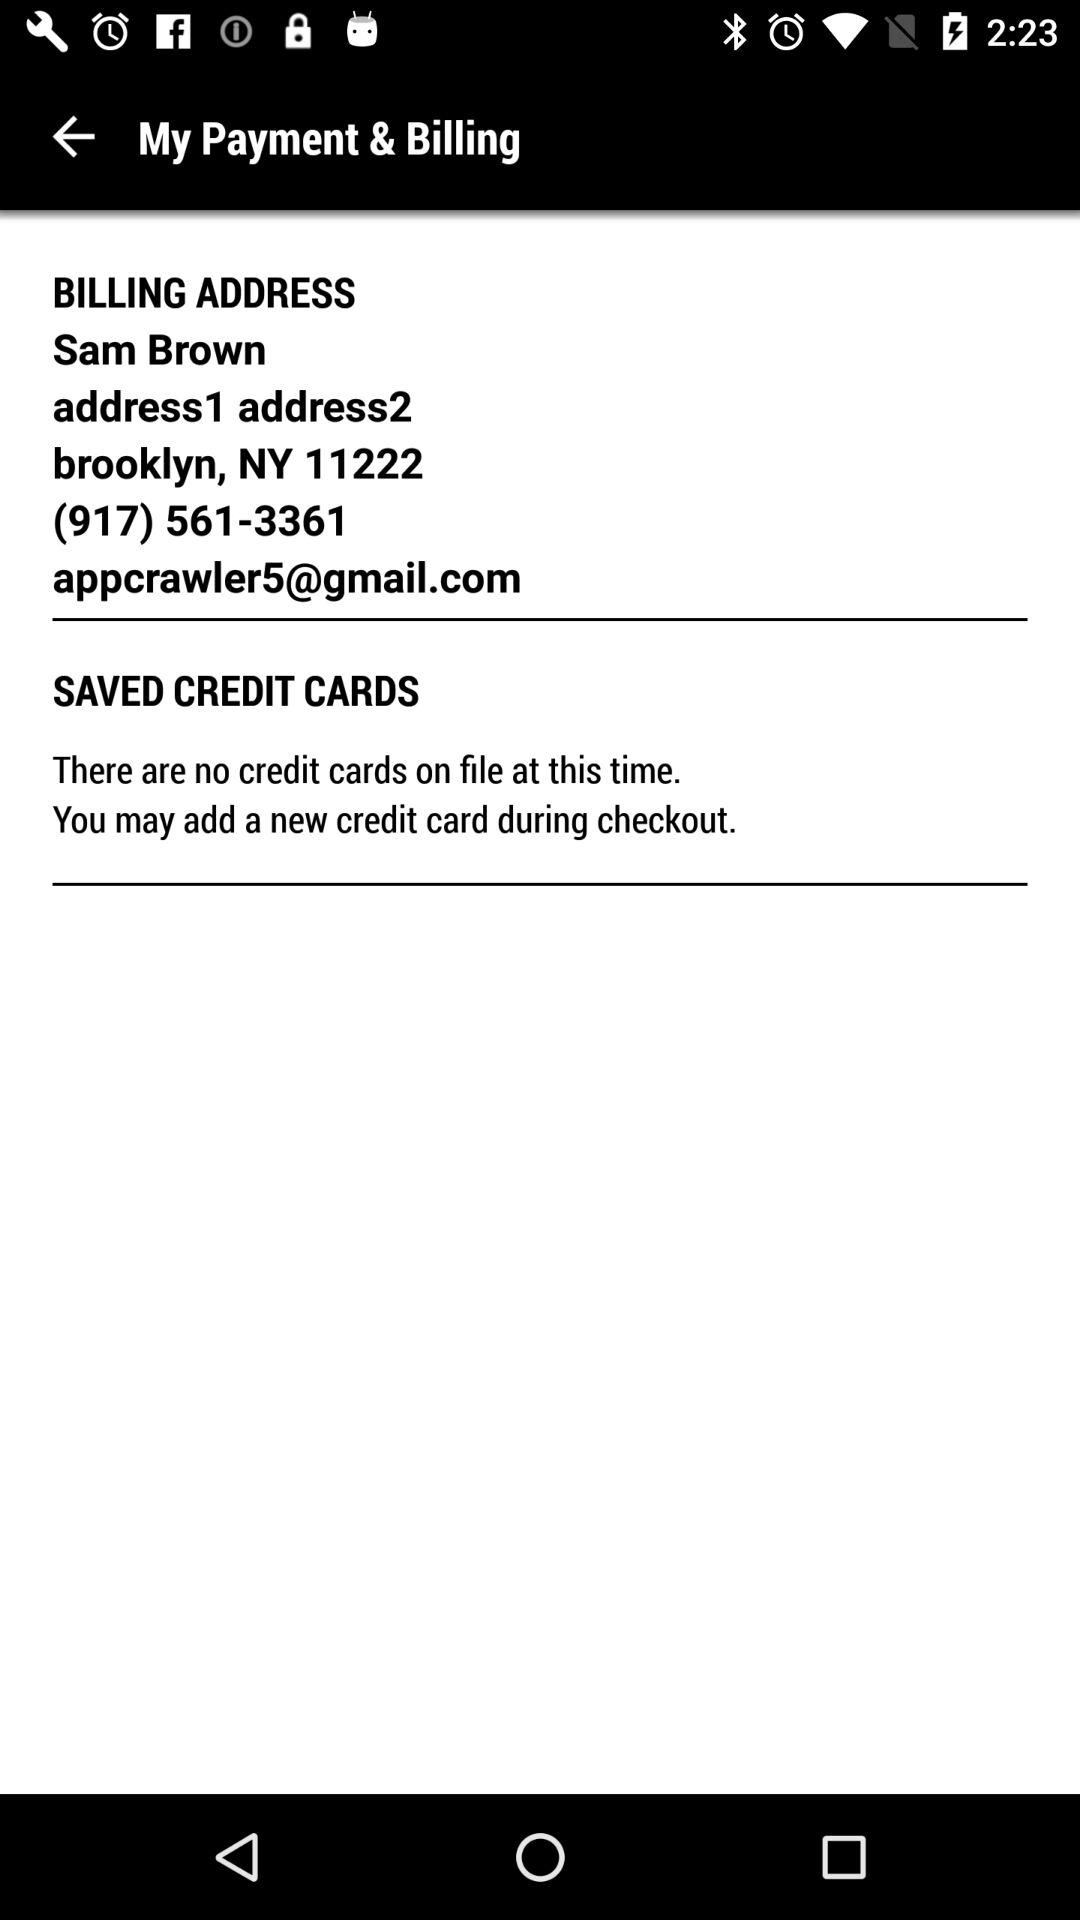What is the email address? The email address is appcrawler5@gmail.com. 